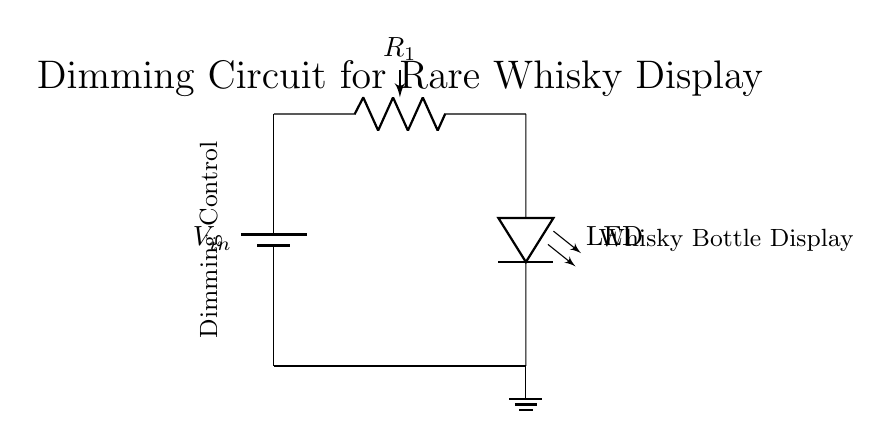What is the input voltage of this circuit? The input voltage is represented by the symbol V_in at the top of the circuit diagram. Since it's labeled as a battery, it implies a certain voltage without specifying an exact value.
Answer: V_in What component is used for dimming control? The potentiometer labeled R_1 in the circuit functions as a variable resistor, which can adjust the resistance and control the brightness of the LED by altering the voltage across it.
Answer: R_1 What is the load component in this circuit? The load is the LED, represented in the diagram, which lights up to showcase the whisky bottles when a suitable voltage is applied across it.
Answer: LED How does the dimming circuit affect the brightness of the LED? The brightness is adjusted by changing the resistance of R_1; as resistance increases, the voltage across the LED decreases, leading to reduced brightness, creating a dimming effect.
Answer: Adjusts brightness What is the function of the ground connection in this circuit? The ground provides a reference point for the circuit's voltage levels, ensuring that the LED and potentiometer are correctly biased against a common zero voltage level, allowing for proper functioning.
Answer: Reference point What would happen if R_1 is set to its maximum resistance? If R_1 is at maximum resistance, the voltage across the LED will drop significantly, likely turning off the LED, therefore diminishing the visibility of the whisky bottles.
Answer: LED turns off What type of circuit is this arrangement exemplifying? This circuit demonstrates a voltage divider configuration, as the input voltage is divided between the potentiometer and the LED based on their resistances.
Answer: Voltage divider 